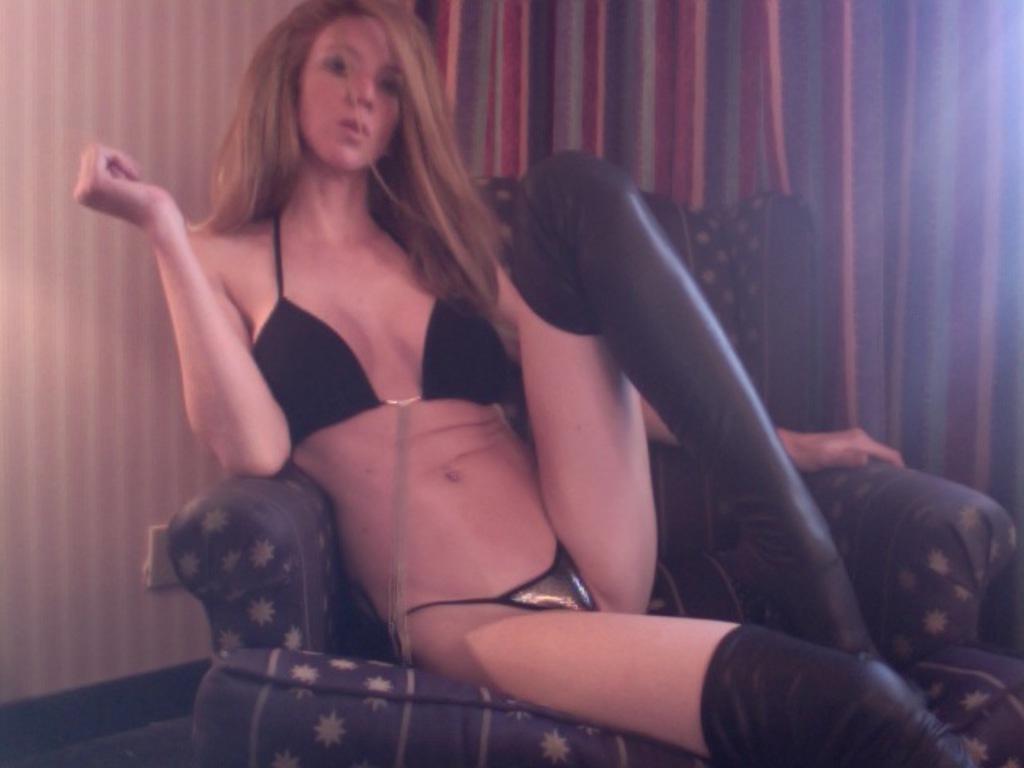How would you summarize this image in a sentence or two? In this image in the center there is one woman who is sitting on a chair, and in the background there is wall and curtain. At the bottom there is floor. 